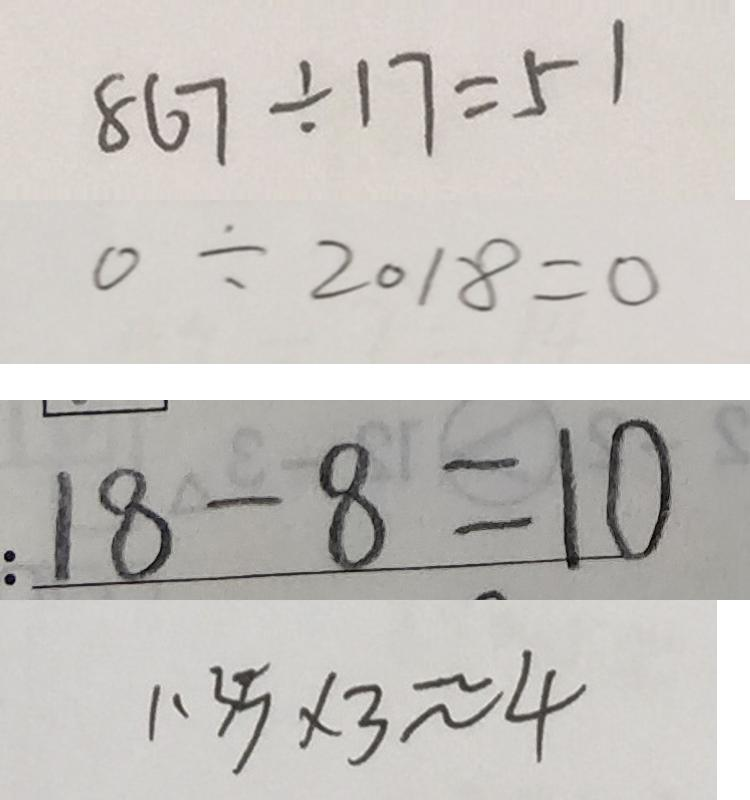Convert formula to latex. <formula><loc_0><loc_0><loc_500><loc_500>8 6 7 \div 1 7 = 5 1 
 0 \div 2 0 1 8 = 0 
 : 1 8 - 8 = 1 0 
 1 . 3 5 \times 3 \approx 4</formula> 